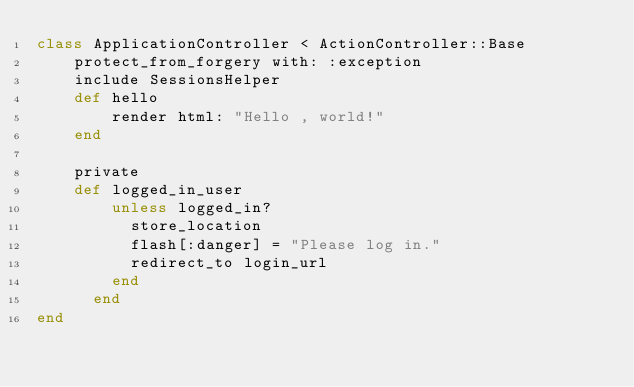<code> <loc_0><loc_0><loc_500><loc_500><_Ruby_>class ApplicationController < ActionController::Base
    protect_from_forgery with: :exception
    include SessionsHelper
    def hello
        render html: "Hello , world!"
    end

    private
    def logged_in_user
        unless logged_in?
          store_location
          flash[:danger] = "Please log in."
          redirect_to login_url
        end
      end
end
</code> 